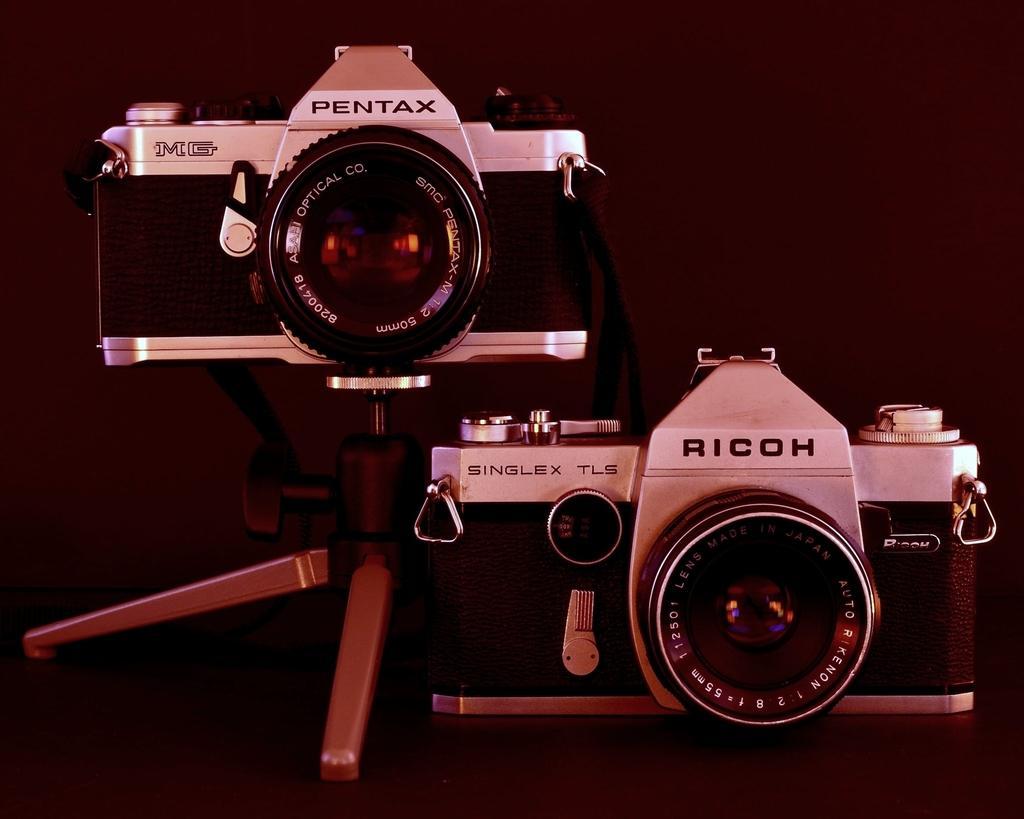Please provide a concise description of this image. There is a camera and another camera with stand on a surface. On the cameras something is written. 